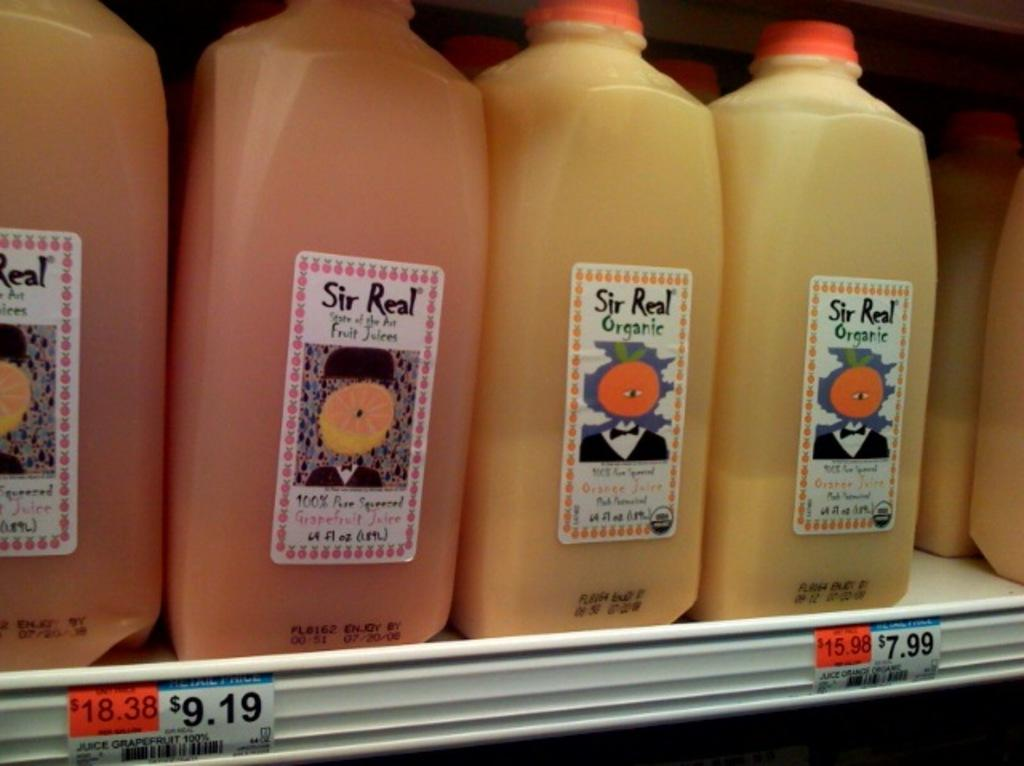What objects can be seen in the image? There are bottles in the image. How are the bottles arranged? The bottles are arranged on a shelf. What is the color of the shelf? The shelf is white in color. Is there any toothpaste visible on the shelf in the image? There is no toothpaste present in the image; only bottles are visible on the shelf. Is the shelf being destroyed in the image? No, the shelf is not being destroyed in the image; it appears to be intact and supporting the bottles. 